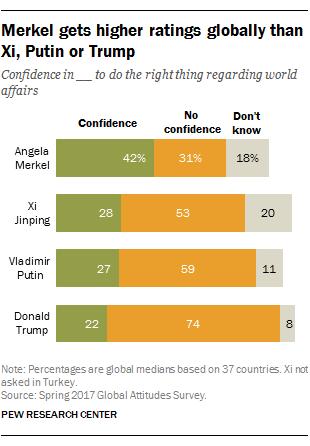Give some essential details in this illustration. According to a survey, 22% of respondents expressed confidence in Donald Trump. The total percentage of confidence, no confidence, and don't know about Vladimir Putin is 97%. 